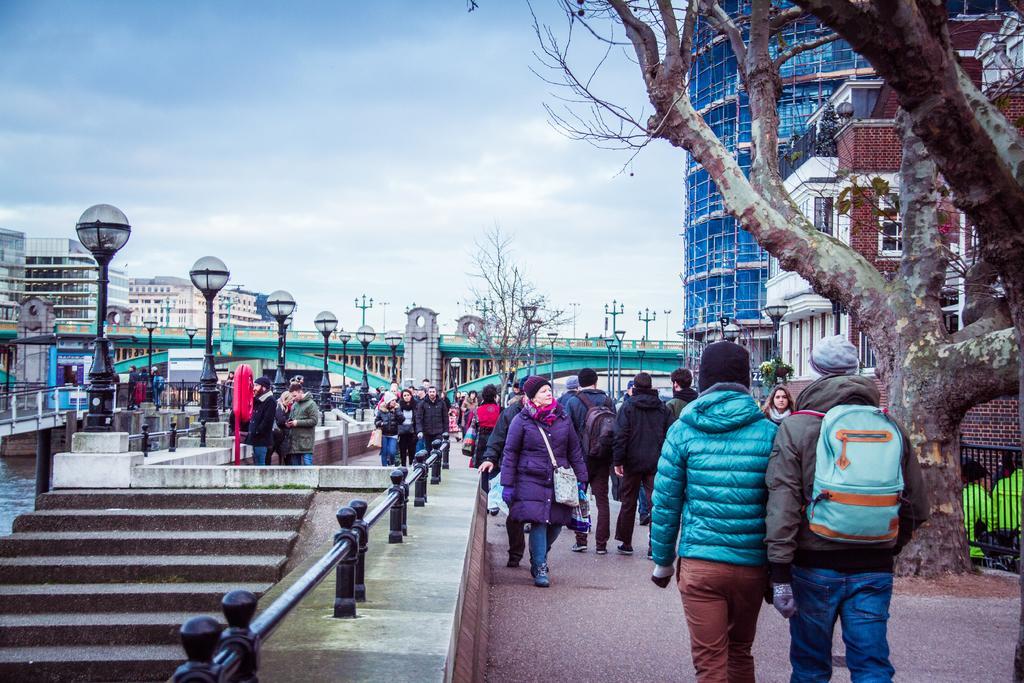Could you give a brief overview of what you see in this image? In the image few people are walking on the road. Bottom left side of the image there are steps and fencing. Top of the image there is a sky and there are some clouds. Top right side of the image there is a tree behind the tree there are some buildings. 